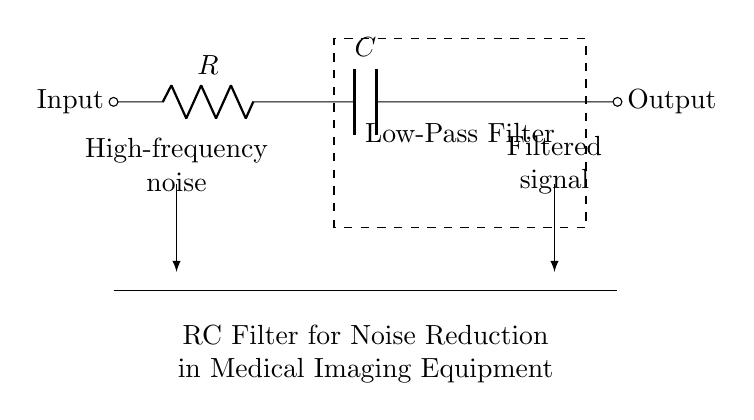What components are in this circuit? The diagram shows a resistor and a capacitor connected in series, with the output taken across the capacitor.
Answer: Resistor and Capacitor What is the primary function of the RC filter in this circuit? The main purpose of this circuit is to act as a low-pass filter, allowing low-frequency signals to pass while attenuating high-frequency noise.
Answer: Low-pass filter What is the placement of the resistor relative to the capacitor? The resistor is placed before the capacitor in the circuit, indicating current flows through the resistor first before reaching the capacitor.
Answer: Before the capacitor What type of noise is this filter designed to reduce? The filter is specifically designed to diminish high-frequency noise, which could interfere with medical imaging accuracy and quality.
Answer: High-frequency noise How does this RC filter affect the output signal? The filter reduces the amplitude of high-frequency components in the output signal, resulting in a cleaner signal that is primarily composed of lower frequency information.
Answer: It attenuates high frequencies What happens if you increase the resistance value in this circuit? Increasing the resistance increases the time constant of the RC circuit, which will allow even more low-frequency signals to pass and further reduce the frequency response for noise.
Answer: Increases time constant 